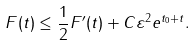Convert formula to latex. <formula><loc_0><loc_0><loc_500><loc_500>F ( t ) \leq \frac { 1 } { 2 } F ^ { \prime } ( t ) + C \varepsilon ^ { 2 } e ^ { t _ { 0 } + t } .</formula> 